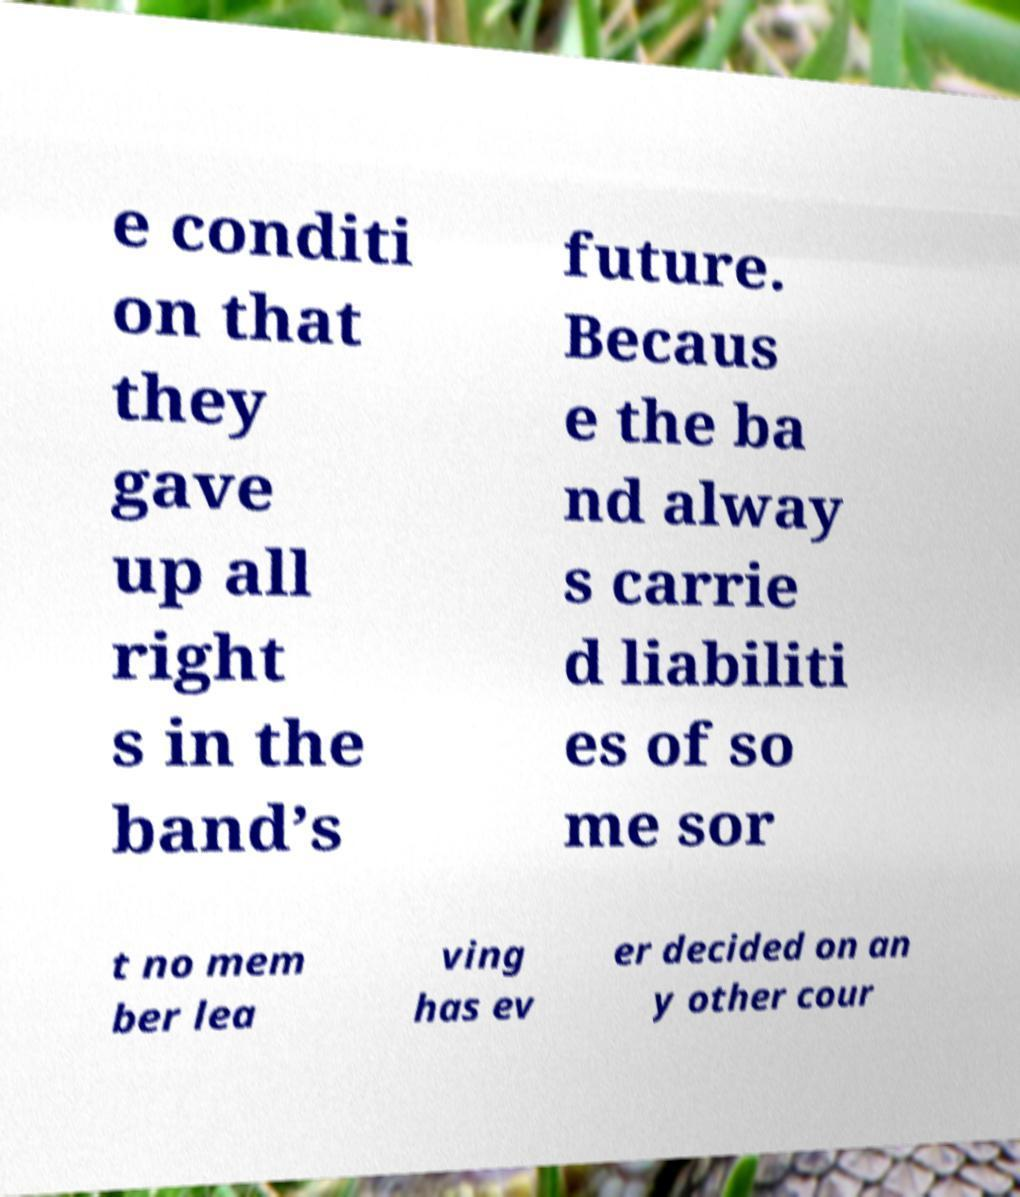Could you assist in decoding the text presented in this image and type it out clearly? e conditi on that they gave up all right s in the band’s future. Becaus e the ba nd alway s carrie d liabiliti es of so me sor t no mem ber lea ving has ev er decided on an y other cour 